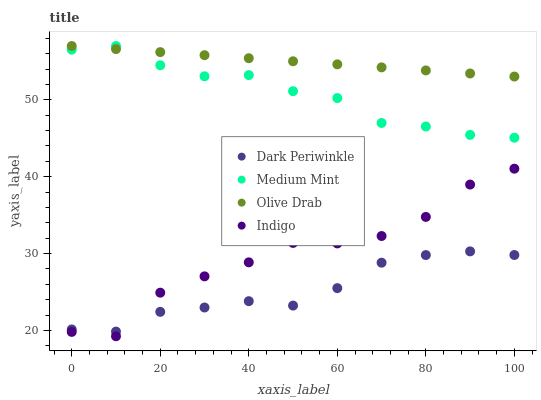Does Dark Periwinkle have the minimum area under the curve?
Answer yes or no. Yes. Does Olive Drab have the maximum area under the curve?
Answer yes or no. Yes. Does Indigo have the minimum area under the curve?
Answer yes or no. No. Does Indigo have the maximum area under the curve?
Answer yes or no. No. Is Olive Drab the smoothest?
Answer yes or no. Yes. Is Indigo the roughest?
Answer yes or no. Yes. Is Dark Periwinkle the smoothest?
Answer yes or no. No. Is Dark Periwinkle the roughest?
Answer yes or no. No. Does Indigo have the lowest value?
Answer yes or no. Yes. Does Dark Periwinkle have the lowest value?
Answer yes or no. No. Does Olive Drab have the highest value?
Answer yes or no. Yes. Does Indigo have the highest value?
Answer yes or no. No. Is Indigo less than Medium Mint?
Answer yes or no. Yes. Is Medium Mint greater than Indigo?
Answer yes or no. Yes. Does Medium Mint intersect Olive Drab?
Answer yes or no. Yes. Is Medium Mint less than Olive Drab?
Answer yes or no. No. Is Medium Mint greater than Olive Drab?
Answer yes or no. No. Does Indigo intersect Medium Mint?
Answer yes or no. No. 